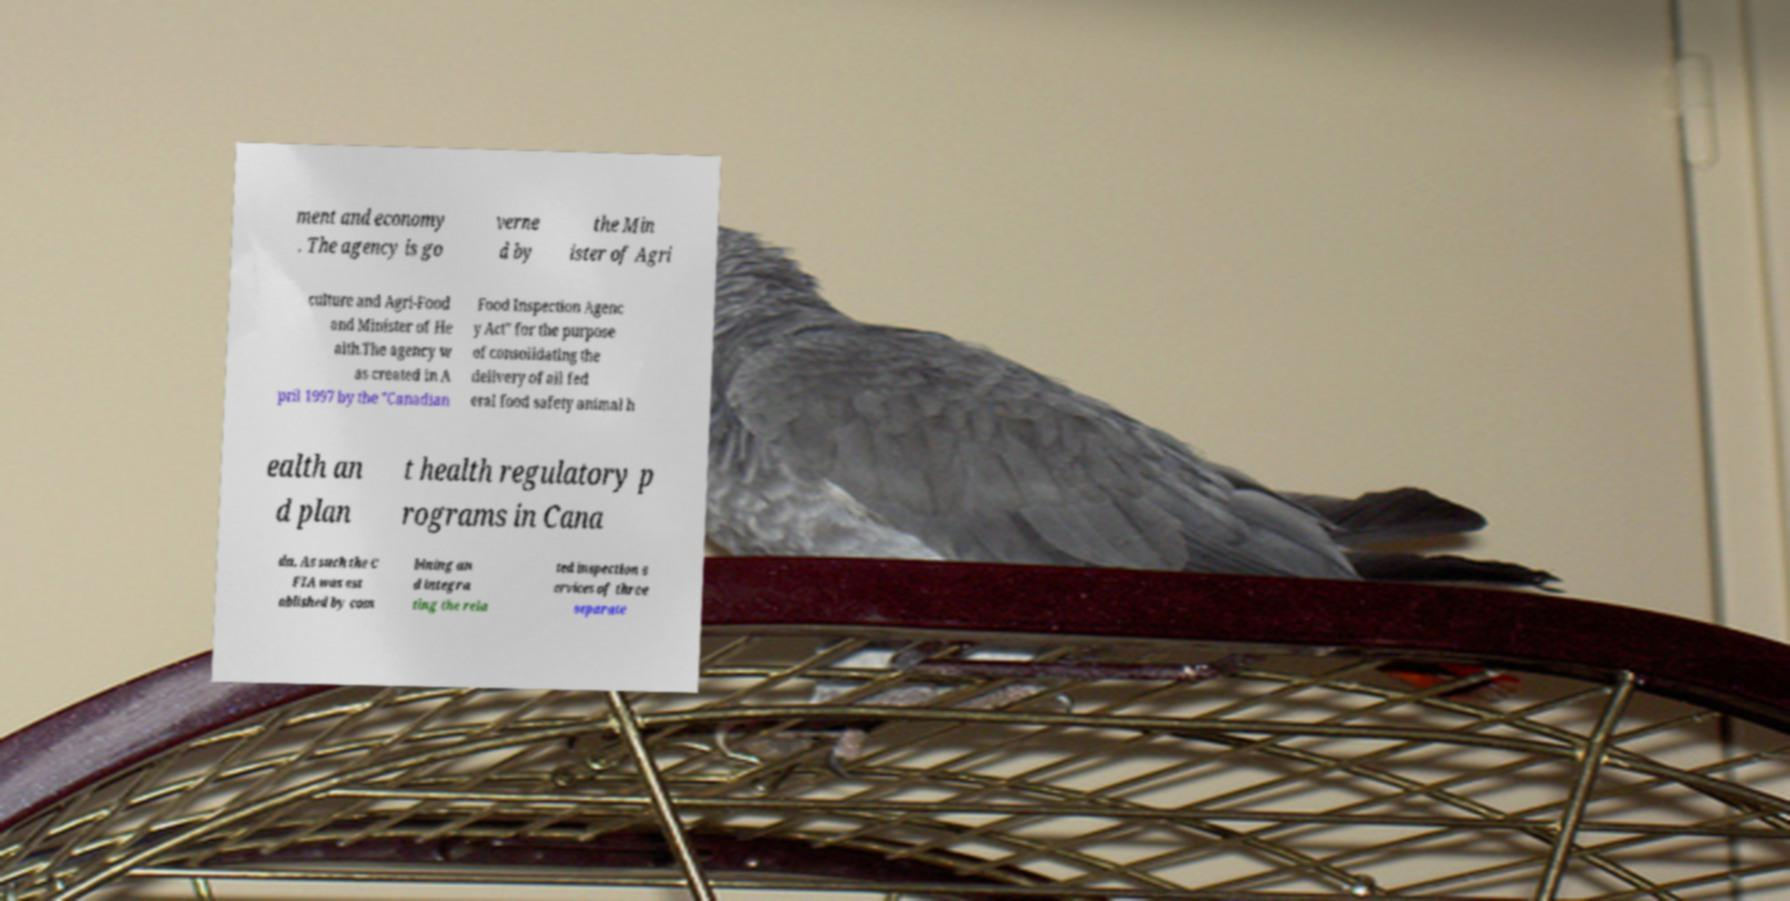Could you assist in decoding the text presented in this image and type it out clearly? ment and economy . The agency is go verne d by the Min ister of Agri culture and Agri-Food and Minister of He alth.The agency w as created in A pril 1997 by the "Canadian Food Inspection Agenc y Act" for the purpose of consolidating the delivery of all fed eral food safety animal h ealth an d plan t health regulatory p rograms in Cana da. As such the C FIA was est ablished by com bining an d integra ting the rela ted inspection s ervices of three separate 